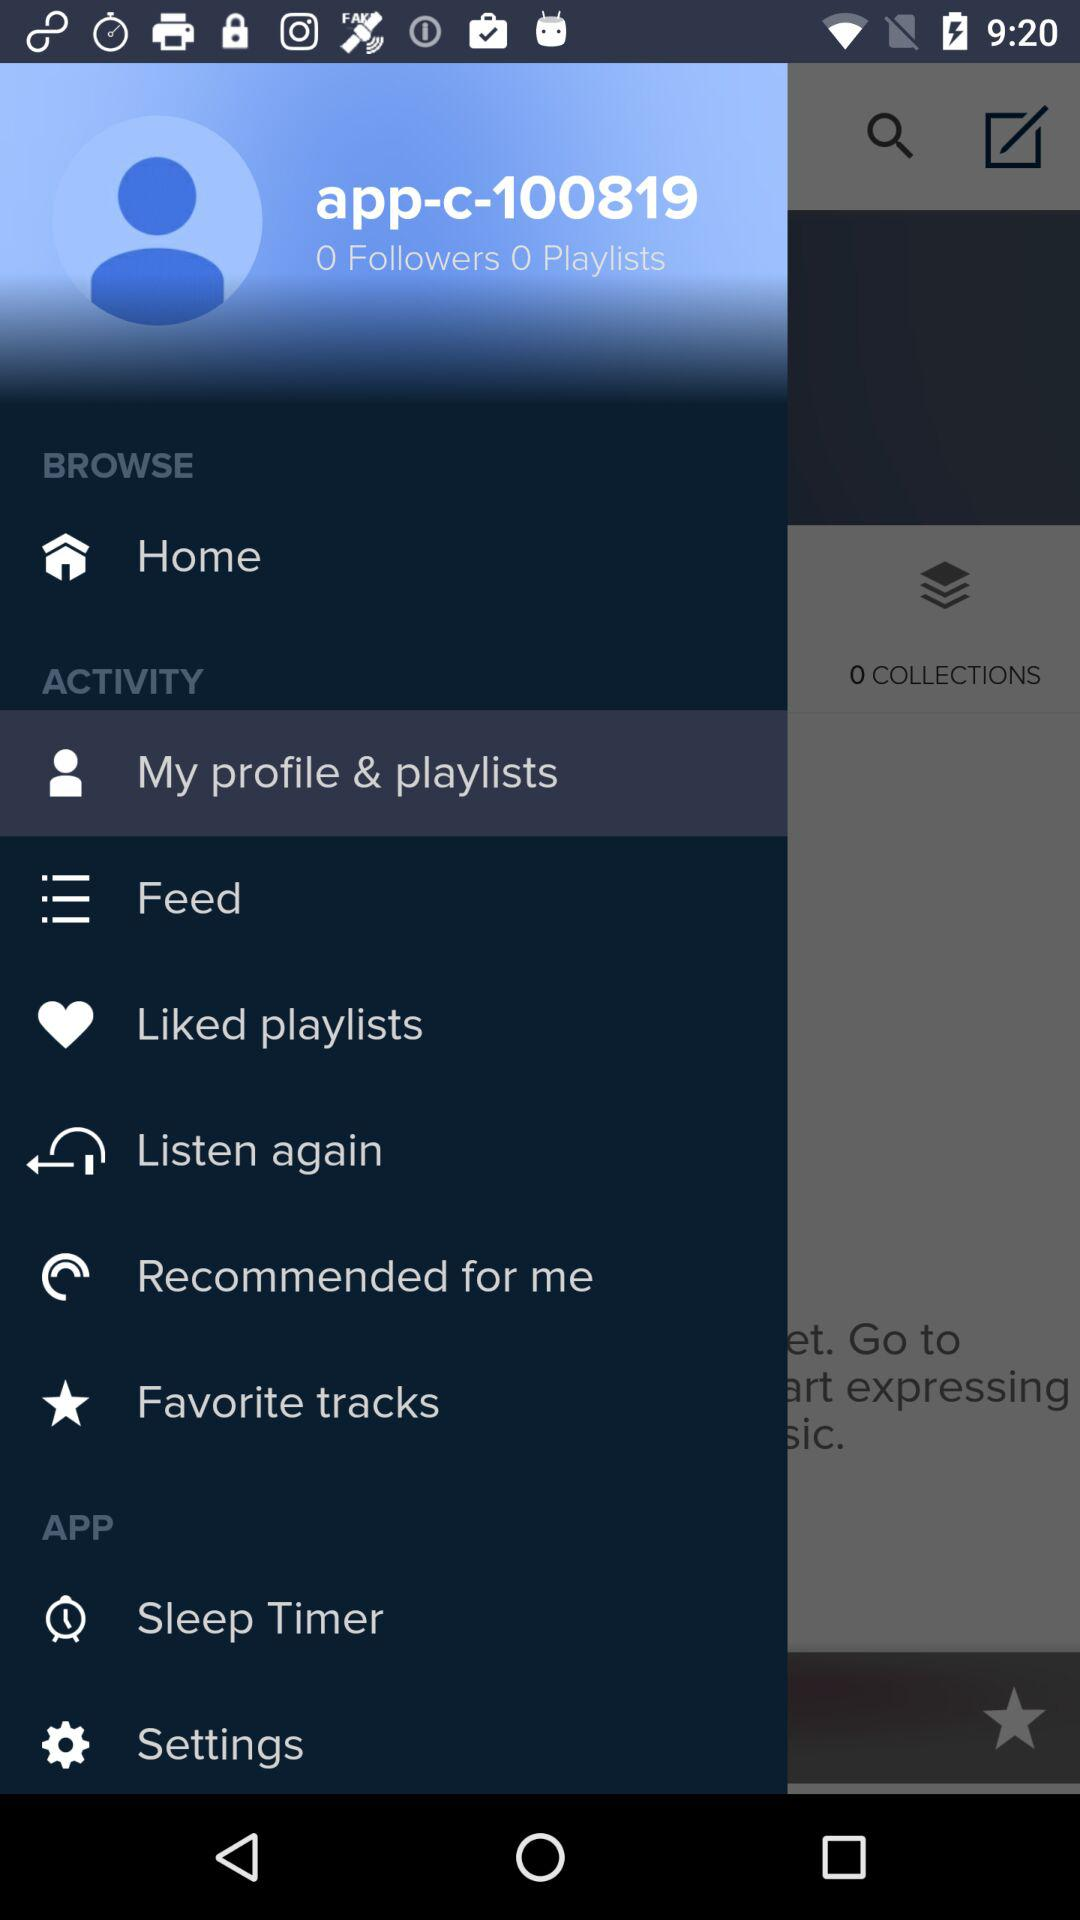What is the number of playlists? The number of playlists is 0. 